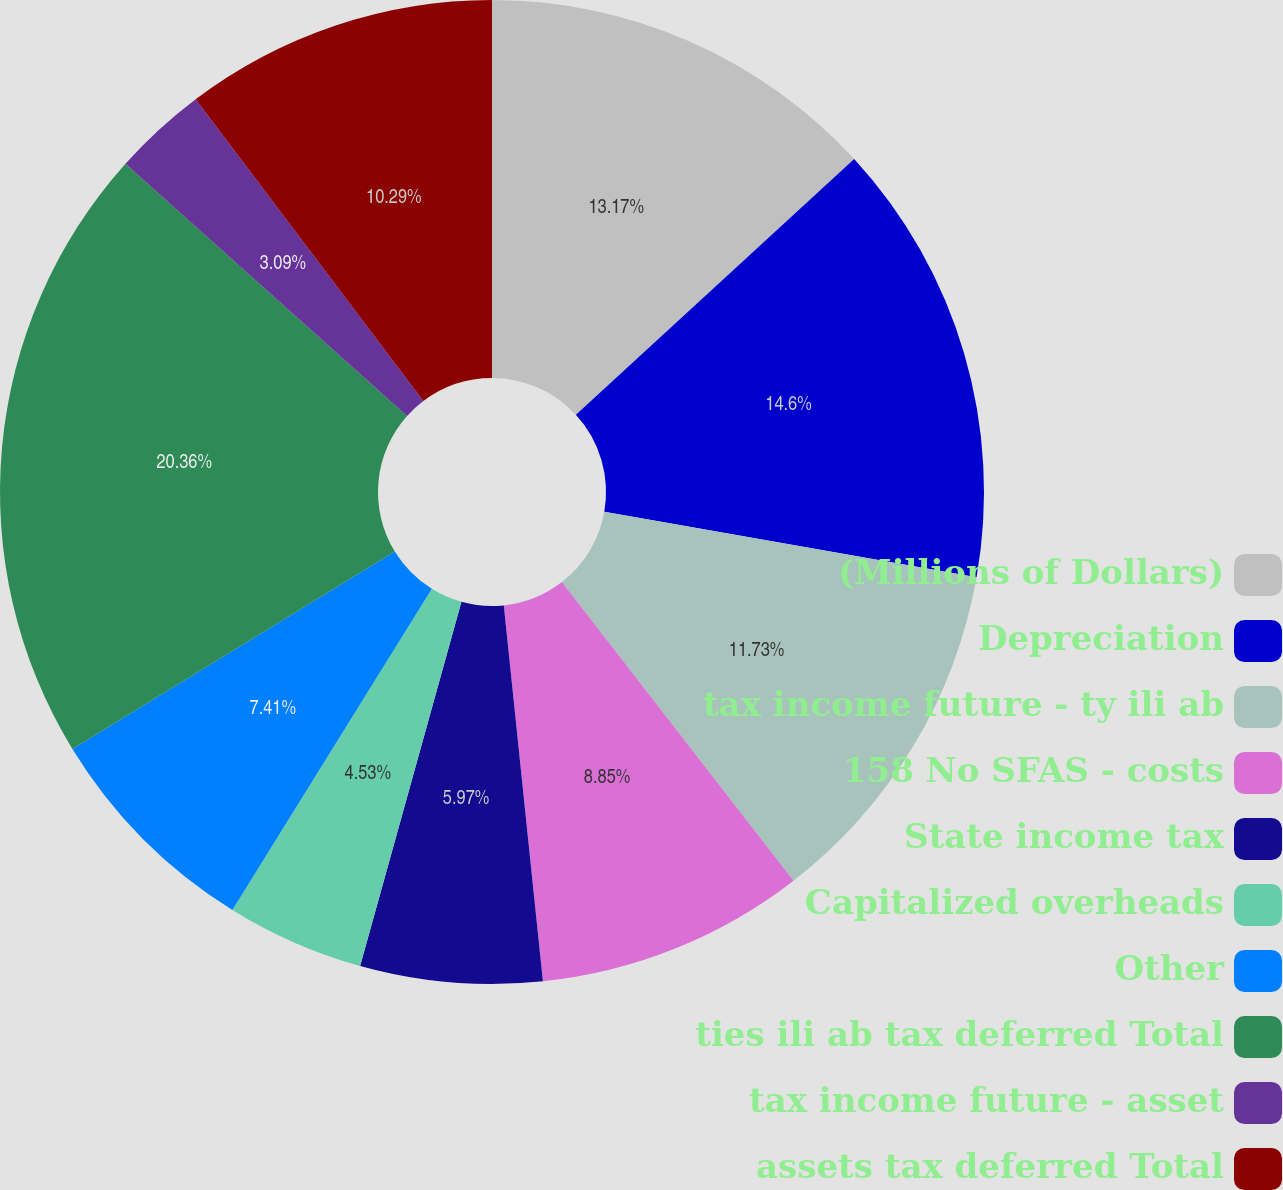Convert chart to OTSL. <chart><loc_0><loc_0><loc_500><loc_500><pie_chart><fcel>(Millions of Dollars)<fcel>Depreciation<fcel>tax income future - ty ili ab<fcel>158 No SFAS - costs<fcel>State income tax<fcel>Capitalized overheads<fcel>Other<fcel>ties ili ab tax deferred Total<fcel>tax income future - asset<fcel>assets tax deferred Total<nl><fcel>13.17%<fcel>14.61%<fcel>11.73%<fcel>8.85%<fcel>5.97%<fcel>4.53%<fcel>7.41%<fcel>20.37%<fcel>3.09%<fcel>10.29%<nl></chart> 